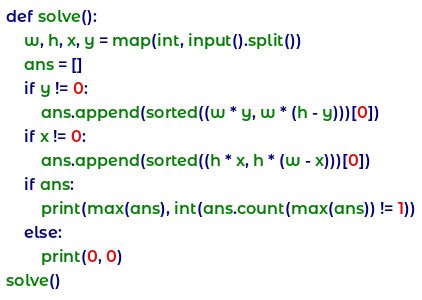Convert code to text. <code><loc_0><loc_0><loc_500><loc_500><_Python_>def solve():
    w, h, x, y = map(int, input().split())
    ans = []
    if y != 0:
        ans.append(sorted((w * y, w * (h - y)))[0])
    if x != 0:
        ans.append(sorted((h * x, h * (w - x)))[0])
    if ans:
        print(max(ans), int(ans.count(max(ans)) != 1))
    else:
        print(0, 0)
solve()
</code> 